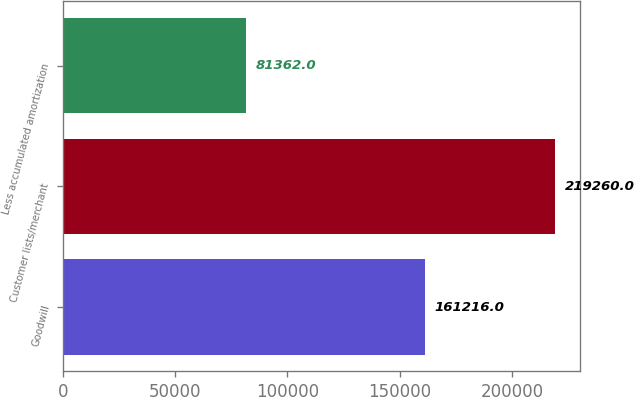Convert chart to OTSL. <chart><loc_0><loc_0><loc_500><loc_500><bar_chart><fcel>Goodwill<fcel>Customer lists/merchant<fcel>Less accumulated amortization<nl><fcel>161216<fcel>219260<fcel>81362<nl></chart> 